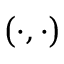Convert formula to latex. <formula><loc_0><loc_0><loc_500><loc_500>\left ( \cdot , \cdot \right )</formula> 